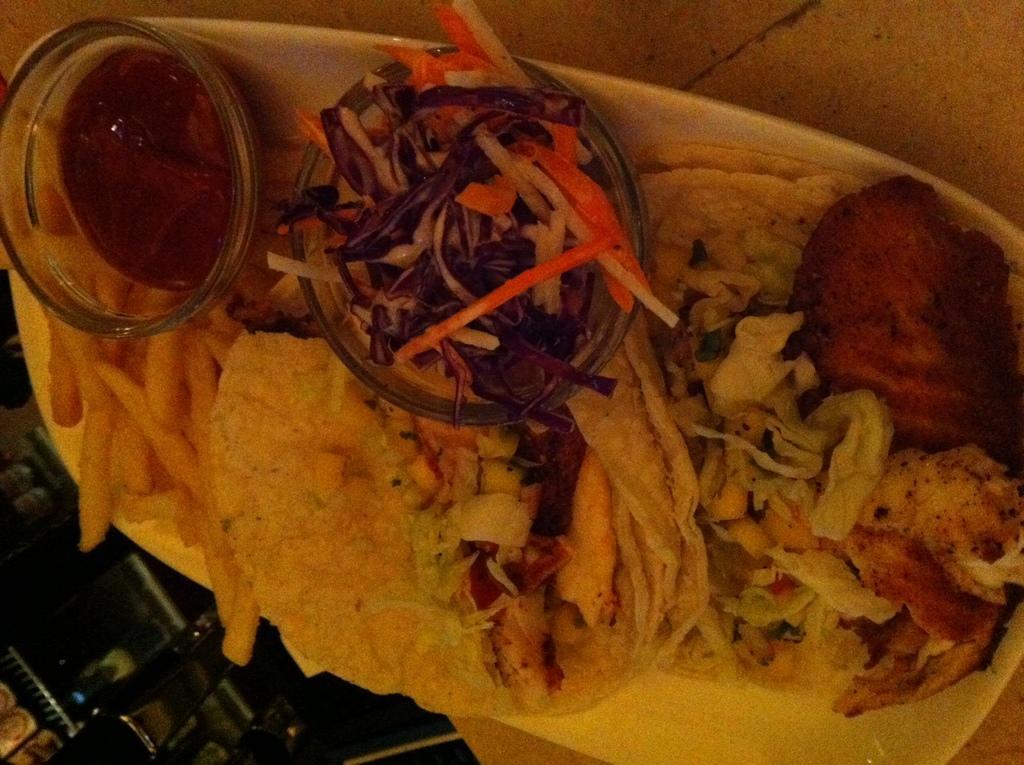Describe this image in one or two sentences. In the middle of this image, there are food items arranged on a white color plate. This plate is placed on a table. In the background, there are other objects. 